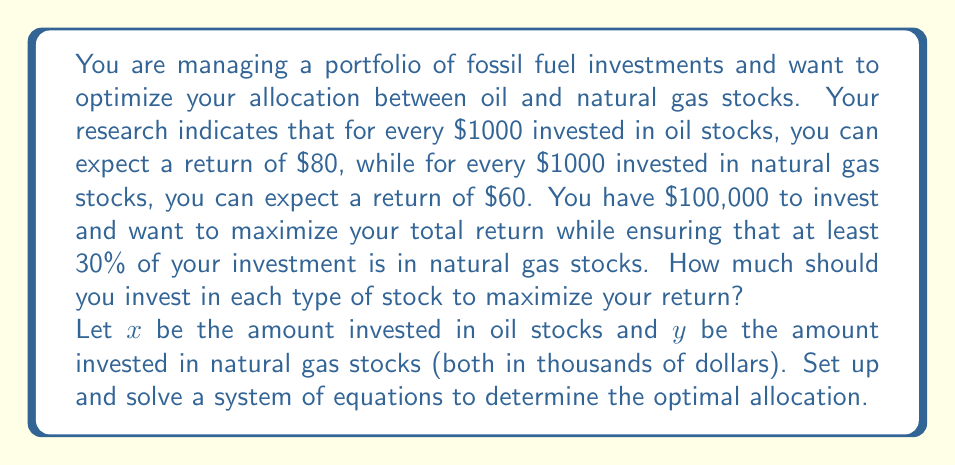What is the answer to this math problem? Let's approach this step-by-step:

1) First, we need to set up our objective function, which represents the total return:
   
   $$ R = 0.08x + 0.06y $$
   
   Where $R$ is the total return, $x$ is the amount invested in oil stocks (in thousands), and $y$ is the amount invested in natural gas stocks (in thousands).

2) Now, we have two constraints:
   a) Total investment constraint: $x + y = 100$ (since we have $100,000 to invest)
   b) Minimum natural gas investment: $y \geq 0.3(x + y)$ or $y \geq 0.3(100)$ = $y \geq 30$

3) To maximize the return, we want to invest as much as possible in oil stocks (which have a higher return) while still meeting the natural gas constraint. This means we should invest exactly 30% in natural gas:

   $y = 30$

4) Using the total investment constraint:

   $x + 30 = 100$
   $x = 70$

5) Let's verify our solution:
   - Total investment: $70 + 30 = 100$ (✓)
   - Natural gas investment: $30$ is 30% of $100 (✓)
   - Return: $R = 0.08(70) + 0.06(30) = 5.6 + 1.8 = 7.4$

Therefore, to maximize return while meeting the constraints, you should invest $70,000 in oil stocks and $30,000 in natural gas stocks, yielding a total return of $7,400.
Answer: $70,000 in oil stocks, $30,000 in natural gas stocks 